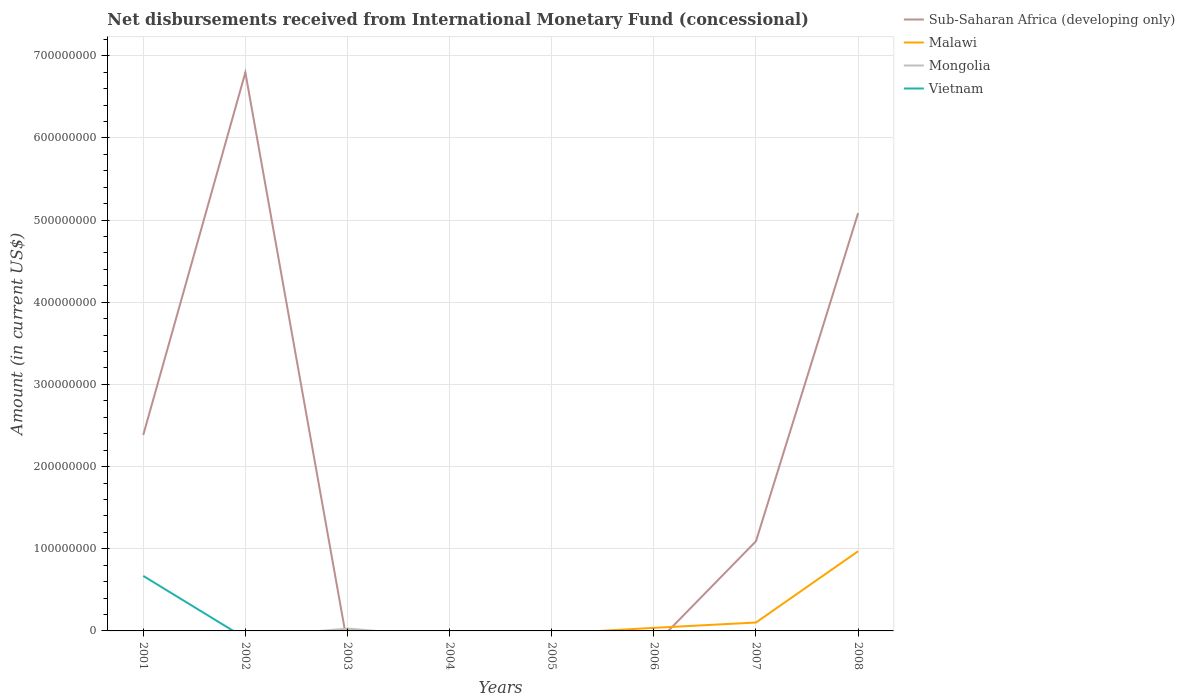How many different coloured lines are there?
Offer a terse response. 4. Does the line corresponding to Vietnam intersect with the line corresponding to Malawi?
Your response must be concise. Yes. What is the total amount of disbursements received from International Monetary Fund in Sub-Saharan Africa (developing only) in the graph?
Make the answer very short. 1.29e+08. What is the difference between the highest and the second highest amount of disbursements received from International Monetary Fund in Malawi?
Your answer should be very brief. 9.70e+07. How many lines are there?
Provide a short and direct response. 4. How many years are there in the graph?
Keep it short and to the point. 8. What is the difference between two consecutive major ticks on the Y-axis?
Make the answer very short. 1.00e+08. Are the values on the major ticks of Y-axis written in scientific E-notation?
Provide a short and direct response. No. Does the graph contain any zero values?
Provide a succinct answer. Yes. Where does the legend appear in the graph?
Offer a terse response. Top right. How many legend labels are there?
Provide a succinct answer. 4. How are the legend labels stacked?
Provide a short and direct response. Vertical. What is the title of the graph?
Offer a terse response. Net disbursements received from International Monetary Fund (concessional). Does "High income: OECD" appear as one of the legend labels in the graph?
Your answer should be very brief. No. What is the label or title of the X-axis?
Give a very brief answer. Years. What is the label or title of the Y-axis?
Provide a succinct answer. Amount (in current US$). What is the Amount (in current US$) of Sub-Saharan Africa (developing only) in 2001?
Keep it short and to the point. 2.38e+08. What is the Amount (in current US$) of Mongolia in 2001?
Your answer should be compact. 0. What is the Amount (in current US$) of Vietnam in 2001?
Give a very brief answer. 6.70e+07. What is the Amount (in current US$) of Sub-Saharan Africa (developing only) in 2002?
Your answer should be compact. 6.80e+08. What is the Amount (in current US$) of Malawi in 2002?
Your answer should be compact. 0. What is the Amount (in current US$) in Mongolia in 2002?
Offer a very short reply. 0. What is the Amount (in current US$) in Vietnam in 2002?
Offer a very short reply. 0. What is the Amount (in current US$) in Malawi in 2003?
Your answer should be compact. 1.41e+06. What is the Amount (in current US$) in Mongolia in 2003?
Provide a short and direct response. 2.82e+06. What is the Amount (in current US$) in Vietnam in 2003?
Ensure brevity in your answer.  0. What is the Amount (in current US$) of Sub-Saharan Africa (developing only) in 2004?
Offer a terse response. 0. What is the Amount (in current US$) in Malawi in 2004?
Make the answer very short. 0. What is the Amount (in current US$) in Vietnam in 2004?
Your answer should be compact. 0. What is the Amount (in current US$) in Malawi in 2005?
Provide a short and direct response. 0. What is the Amount (in current US$) of Malawi in 2006?
Your response must be concise. 3.74e+06. What is the Amount (in current US$) in Sub-Saharan Africa (developing only) in 2007?
Keep it short and to the point. 1.09e+08. What is the Amount (in current US$) of Malawi in 2007?
Keep it short and to the point. 1.02e+07. What is the Amount (in current US$) of Sub-Saharan Africa (developing only) in 2008?
Provide a short and direct response. 5.08e+08. What is the Amount (in current US$) of Malawi in 2008?
Make the answer very short. 9.70e+07. Across all years, what is the maximum Amount (in current US$) of Sub-Saharan Africa (developing only)?
Your response must be concise. 6.80e+08. Across all years, what is the maximum Amount (in current US$) in Malawi?
Your answer should be very brief. 9.70e+07. Across all years, what is the maximum Amount (in current US$) of Mongolia?
Give a very brief answer. 2.82e+06. Across all years, what is the maximum Amount (in current US$) of Vietnam?
Ensure brevity in your answer.  6.70e+07. Across all years, what is the minimum Amount (in current US$) in Sub-Saharan Africa (developing only)?
Offer a terse response. 0. Across all years, what is the minimum Amount (in current US$) in Malawi?
Your answer should be very brief. 0. Across all years, what is the minimum Amount (in current US$) in Vietnam?
Your answer should be very brief. 0. What is the total Amount (in current US$) in Sub-Saharan Africa (developing only) in the graph?
Your response must be concise. 1.54e+09. What is the total Amount (in current US$) of Malawi in the graph?
Make the answer very short. 1.12e+08. What is the total Amount (in current US$) of Mongolia in the graph?
Keep it short and to the point. 2.82e+06. What is the total Amount (in current US$) of Vietnam in the graph?
Make the answer very short. 6.70e+07. What is the difference between the Amount (in current US$) in Sub-Saharan Africa (developing only) in 2001 and that in 2002?
Your answer should be compact. -4.41e+08. What is the difference between the Amount (in current US$) of Sub-Saharan Africa (developing only) in 2001 and that in 2007?
Offer a terse response. 1.29e+08. What is the difference between the Amount (in current US$) of Sub-Saharan Africa (developing only) in 2001 and that in 2008?
Keep it short and to the point. -2.70e+08. What is the difference between the Amount (in current US$) of Sub-Saharan Africa (developing only) in 2002 and that in 2007?
Offer a very short reply. 5.70e+08. What is the difference between the Amount (in current US$) in Sub-Saharan Africa (developing only) in 2002 and that in 2008?
Make the answer very short. 1.71e+08. What is the difference between the Amount (in current US$) of Malawi in 2003 and that in 2006?
Offer a very short reply. -2.32e+06. What is the difference between the Amount (in current US$) in Malawi in 2003 and that in 2007?
Provide a short and direct response. -8.81e+06. What is the difference between the Amount (in current US$) in Malawi in 2003 and that in 2008?
Give a very brief answer. -9.55e+07. What is the difference between the Amount (in current US$) of Malawi in 2006 and that in 2007?
Make the answer very short. -6.49e+06. What is the difference between the Amount (in current US$) of Malawi in 2006 and that in 2008?
Your answer should be very brief. -9.32e+07. What is the difference between the Amount (in current US$) of Sub-Saharan Africa (developing only) in 2007 and that in 2008?
Your answer should be very brief. -3.99e+08. What is the difference between the Amount (in current US$) of Malawi in 2007 and that in 2008?
Your answer should be very brief. -8.67e+07. What is the difference between the Amount (in current US$) in Sub-Saharan Africa (developing only) in 2001 and the Amount (in current US$) in Malawi in 2003?
Keep it short and to the point. 2.37e+08. What is the difference between the Amount (in current US$) in Sub-Saharan Africa (developing only) in 2001 and the Amount (in current US$) in Mongolia in 2003?
Keep it short and to the point. 2.36e+08. What is the difference between the Amount (in current US$) of Sub-Saharan Africa (developing only) in 2001 and the Amount (in current US$) of Malawi in 2006?
Make the answer very short. 2.35e+08. What is the difference between the Amount (in current US$) in Sub-Saharan Africa (developing only) in 2001 and the Amount (in current US$) in Malawi in 2007?
Your answer should be compact. 2.28e+08. What is the difference between the Amount (in current US$) in Sub-Saharan Africa (developing only) in 2001 and the Amount (in current US$) in Malawi in 2008?
Provide a succinct answer. 1.41e+08. What is the difference between the Amount (in current US$) of Sub-Saharan Africa (developing only) in 2002 and the Amount (in current US$) of Malawi in 2003?
Your response must be concise. 6.78e+08. What is the difference between the Amount (in current US$) of Sub-Saharan Africa (developing only) in 2002 and the Amount (in current US$) of Mongolia in 2003?
Your answer should be very brief. 6.77e+08. What is the difference between the Amount (in current US$) of Sub-Saharan Africa (developing only) in 2002 and the Amount (in current US$) of Malawi in 2006?
Your answer should be compact. 6.76e+08. What is the difference between the Amount (in current US$) of Sub-Saharan Africa (developing only) in 2002 and the Amount (in current US$) of Malawi in 2007?
Give a very brief answer. 6.69e+08. What is the difference between the Amount (in current US$) in Sub-Saharan Africa (developing only) in 2002 and the Amount (in current US$) in Malawi in 2008?
Give a very brief answer. 5.83e+08. What is the difference between the Amount (in current US$) in Sub-Saharan Africa (developing only) in 2007 and the Amount (in current US$) in Malawi in 2008?
Your answer should be very brief. 1.22e+07. What is the average Amount (in current US$) of Sub-Saharan Africa (developing only) per year?
Make the answer very short. 1.92e+08. What is the average Amount (in current US$) of Malawi per year?
Your response must be concise. 1.40e+07. What is the average Amount (in current US$) of Mongolia per year?
Provide a succinct answer. 3.53e+05. What is the average Amount (in current US$) in Vietnam per year?
Your answer should be very brief. 8.37e+06. In the year 2001, what is the difference between the Amount (in current US$) of Sub-Saharan Africa (developing only) and Amount (in current US$) of Vietnam?
Make the answer very short. 1.71e+08. In the year 2003, what is the difference between the Amount (in current US$) in Malawi and Amount (in current US$) in Mongolia?
Keep it short and to the point. -1.41e+06. In the year 2007, what is the difference between the Amount (in current US$) of Sub-Saharan Africa (developing only) and Amount (in current US$) of Malawi?
Make the answer very short. 9.89e+07. In the year 2008, what is the difference between the Amount (in current US$) of Sub-Saharan Africa (developing only) and Amount (in current US$) of Malawi?
Your answer should be compact. 4.12e+08. What is the ratio of the Amount (in current US$) in Sub-Saharan Africa (developing only) in 2001 to that in 2002?
Keep it short and to the point. 0.35. What is the ratio of the Amount (in current US$) of Sub-Saharan Africa (developing only) in 2001 to that in 2007?
Offer a terse response. 2.18. What is the ratio of the Amount (in current US$) in Sub-Saharan Africa (developing only) in 2001 to that in 2008?
Ensure brevity in your answer.  0.47. What is the ratio of the Amount (in current US$) of Sub-Saharan Africa (developing only) in 2002 to that in 2007?
Your response must be concise. 6.23. What is the ratio of the Amount (in current US$) of Sub-Saharan Africa (developing only) in 2002 to that in 2008?
Make the answer very short. 1.34. What is the ratio of the Amount (in current US$) in Malawi in 2003 to that in 2006?
Your answer should be very brief. 0.38. What is the ratio of the Amount (in current US$) of Malawi in 2003 to that in 2007?
Your answer should be very brief. 0.14. What is the ratio of the Amount (in current US$) in Malawi in 2003 to that in 2008?
Offer a very short reply. 0.01. What is the ratio of the Amount (in current US$) in Malawi in 2006 to that in 2007?
Give a very brief answer. 0.37. What is the ratio of the Amount (in current US$) in Malawi in 2006 to that in 2008?
Keep it short and to the point. 0.04. What is the ratio of the Amount (in current US$) in Sub-Saharan Africa (developing only) in 2007 to that in 2008?
Provide a succinct answer. 0.21. What is the ratio of the Amount (in current US$) in Malawi in 2007 to that in 2008?
Offer a very short reply. 0.11. What is the difference between the highest and the second highest Amount (in current US$) in Sub-Saharan Africa (developing only)?
Offer a terse response. 1.71e+08. What is the difference between the highest and the second highest Amount (in current US$) of Malawi?
Ensure brevity in your answer.  8.67e+07. What is the difference between the highest and the lowest Amount (in current US$) in Sub-Saharan Africa (developing only)?
Provide a short and direct response. 6.80e+08. What is the difference between the highest and the lowest Amount (in current US$) of Malawi?
Make the answer very short. 9.70e+07. What is the difference between the highest and the lowest Amount (in current US$) of Mongolia?
Offer a terse response. 2.82e+06. What is the difference between the highest and the lowest Amount (in current US$) of Vietnam?
Your answer should be very brief. 6.70e+07. 